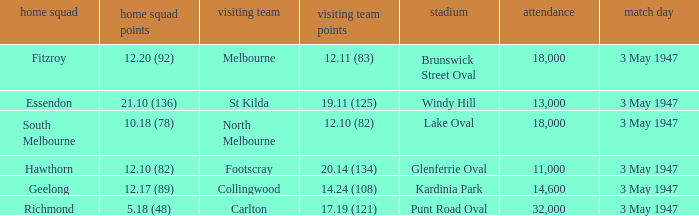In the game where the home team scored 12.17 (89), who was the home team? Geelong. 